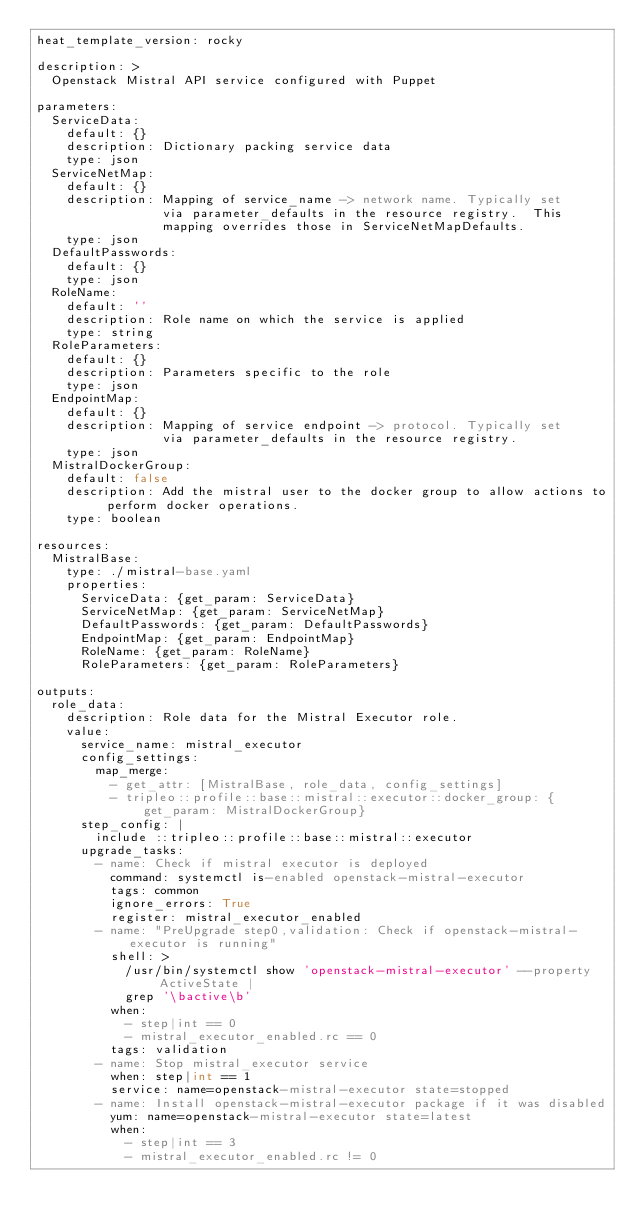Convert code to text. <code><loc_0><loc_0><loc_500><loc_500><_YAML_>heat_template_version: rocky

description: >
  Openstack Mistral API service configured with Puppet

parameters:
  ServiceData:
    default: {}
    description: Dictionary packing service data
    type: json
  ServiceNetMap:
    default: {}
    description: Mapping of service_name -> network name. Typically set
                 via parameter_defaults in the resource registry.  This
                 mapping overrides those in ServiceNetMapDefaults.
    type: json
  DefaultPasswords:
    default: {}
    type: json
  RoleName:
    default: ''
    description: Role name on which the service is applied
    type: string
  RoleParameters:
    default: {}
    description: Parameters specific to the role
    type: json
  EndpointMap:
    default: {}
    description: Mapping of service endpoint -> protocol. Typically set
                 via parameter_defaults in the resource registry.
    type: json
  MistralDockerGroup:
    default: false
    description: Add the mistral user to the docker group to allow actions to perform docker operations.
    type: boolean

resources:
  MistralBase:
    type: ./mistral-base.yaml
    properties:
      ServiceData: {get_param: ServiceData}
      ServiceNetMap: {get_param: ServiceNetMap}
      DefaultPasswords: {get_param: DefaultPasswords}
      EndpointMap: {get_param: EndpointMap}
      RoleName: {get_param: RoleName}
      RoleParameters: {get_param: RoleParameters}

outputs:
  role_data:
    description: Role data for the Mistral Executor role.
    value:
      service_name: mistral_executor
      config_settings:
        map_merge:
          - get_attr: [MistralBase, role_data, config_settings]
          - tripleo::profile::base::mistral::executor::docker_group: {get_param: MistralDockerGroup}
      step_config: |
        include ::tripleo::profile::base::mistral::executor
      upgrade_tasks:
        - name: Check if mistral executor is deployed
          command: systemctl is-enabled openstack-mistral-executor
          tags: common
          ignore_errors: True
          register: mistral_executor_enabled
        - name: "PreUpgrade step0,validation: Check if openstack-mistral-executor is running"
          shell: >
            /usr/bin/systemctl show 'openstack-mistral-executor' --property ActiveState |
            grep '\bactive\b'
          when:
            - step|int == 0
            - mistral_executor_enabled.rc == 0
          tags: validation
        - name: Stop mistral_executor service
          when: step|int == 1
          service: name=openstack-mistral-executor state=stopped
        - name: Install openstack-mistral-executor package if it was disabled
          yum: name=openstack-mistral-executor state=latest
          when:
            - step|int == 3
            - mistral_executor_enabled.rc != 0
</code> 